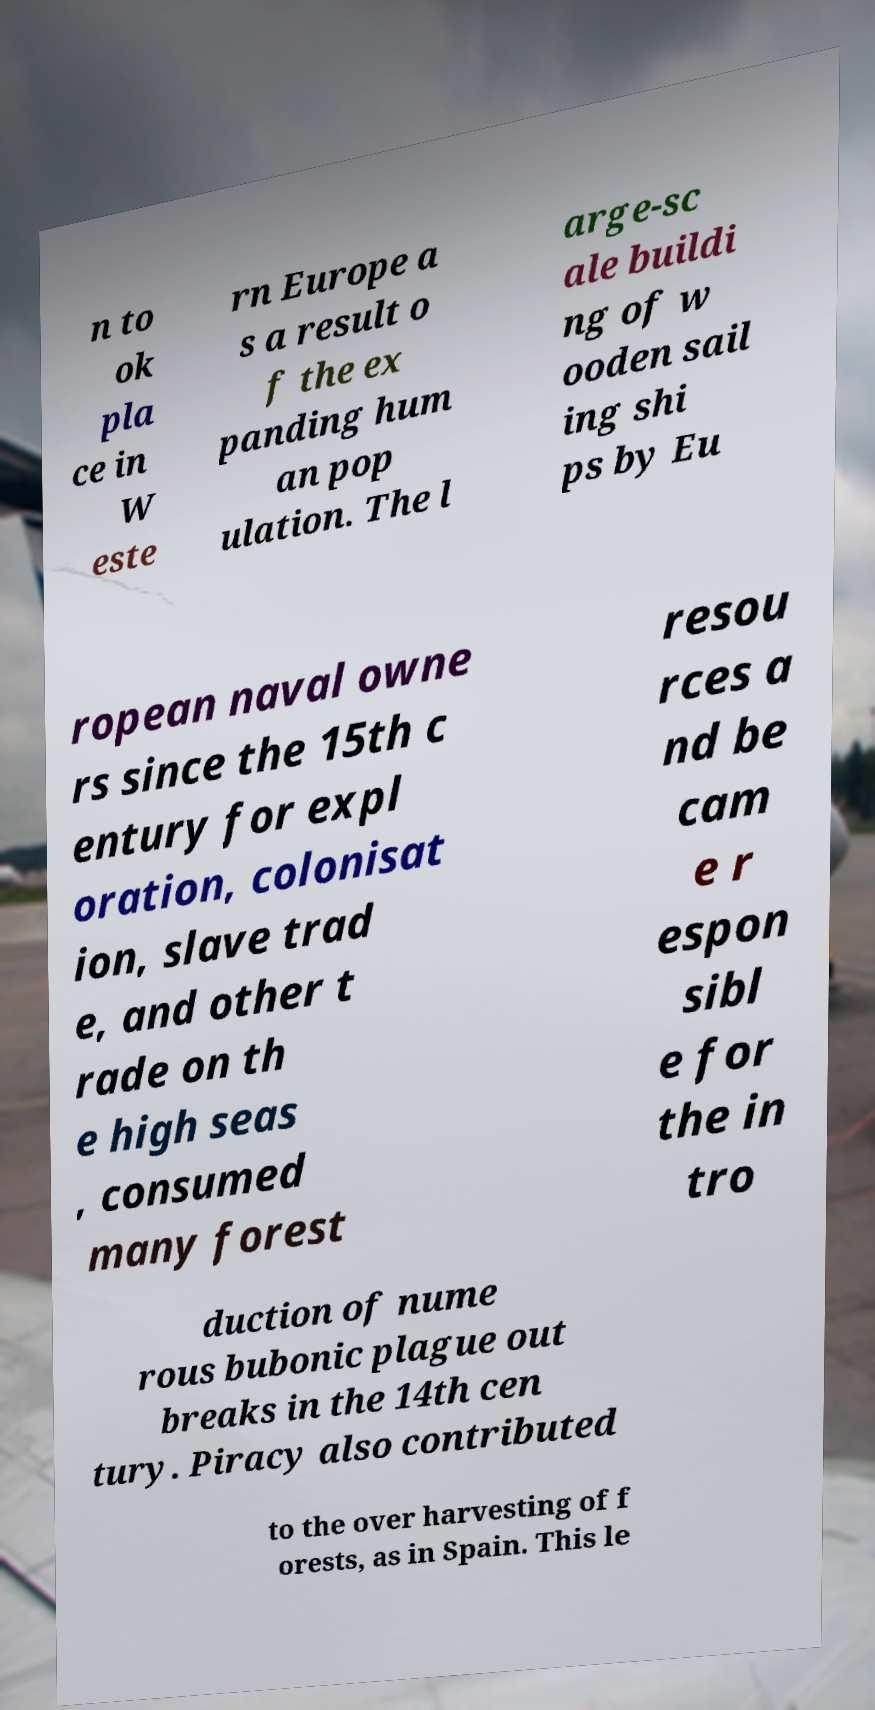Can you accurately transcribe the text from the provided image for me? n to ok pla ce in W este rn Europe a s a result o f the ex panding hum an pop ulation. The l arge-sc ale buildi ng of w ooden sail ing shi ps by Eu ropean naval owne rs since the 15th c entury for expl oration, colonisat ion, slave trad e, and other t rade on th e high seas , consumed many forest resou rces a nd be cam e r espon sibl e for the in tro duction of nume rous bubonic plague out breaks in the 14th cen tury. Piracy also contributed to the over harvesting of f orests, as in Spain. This le 